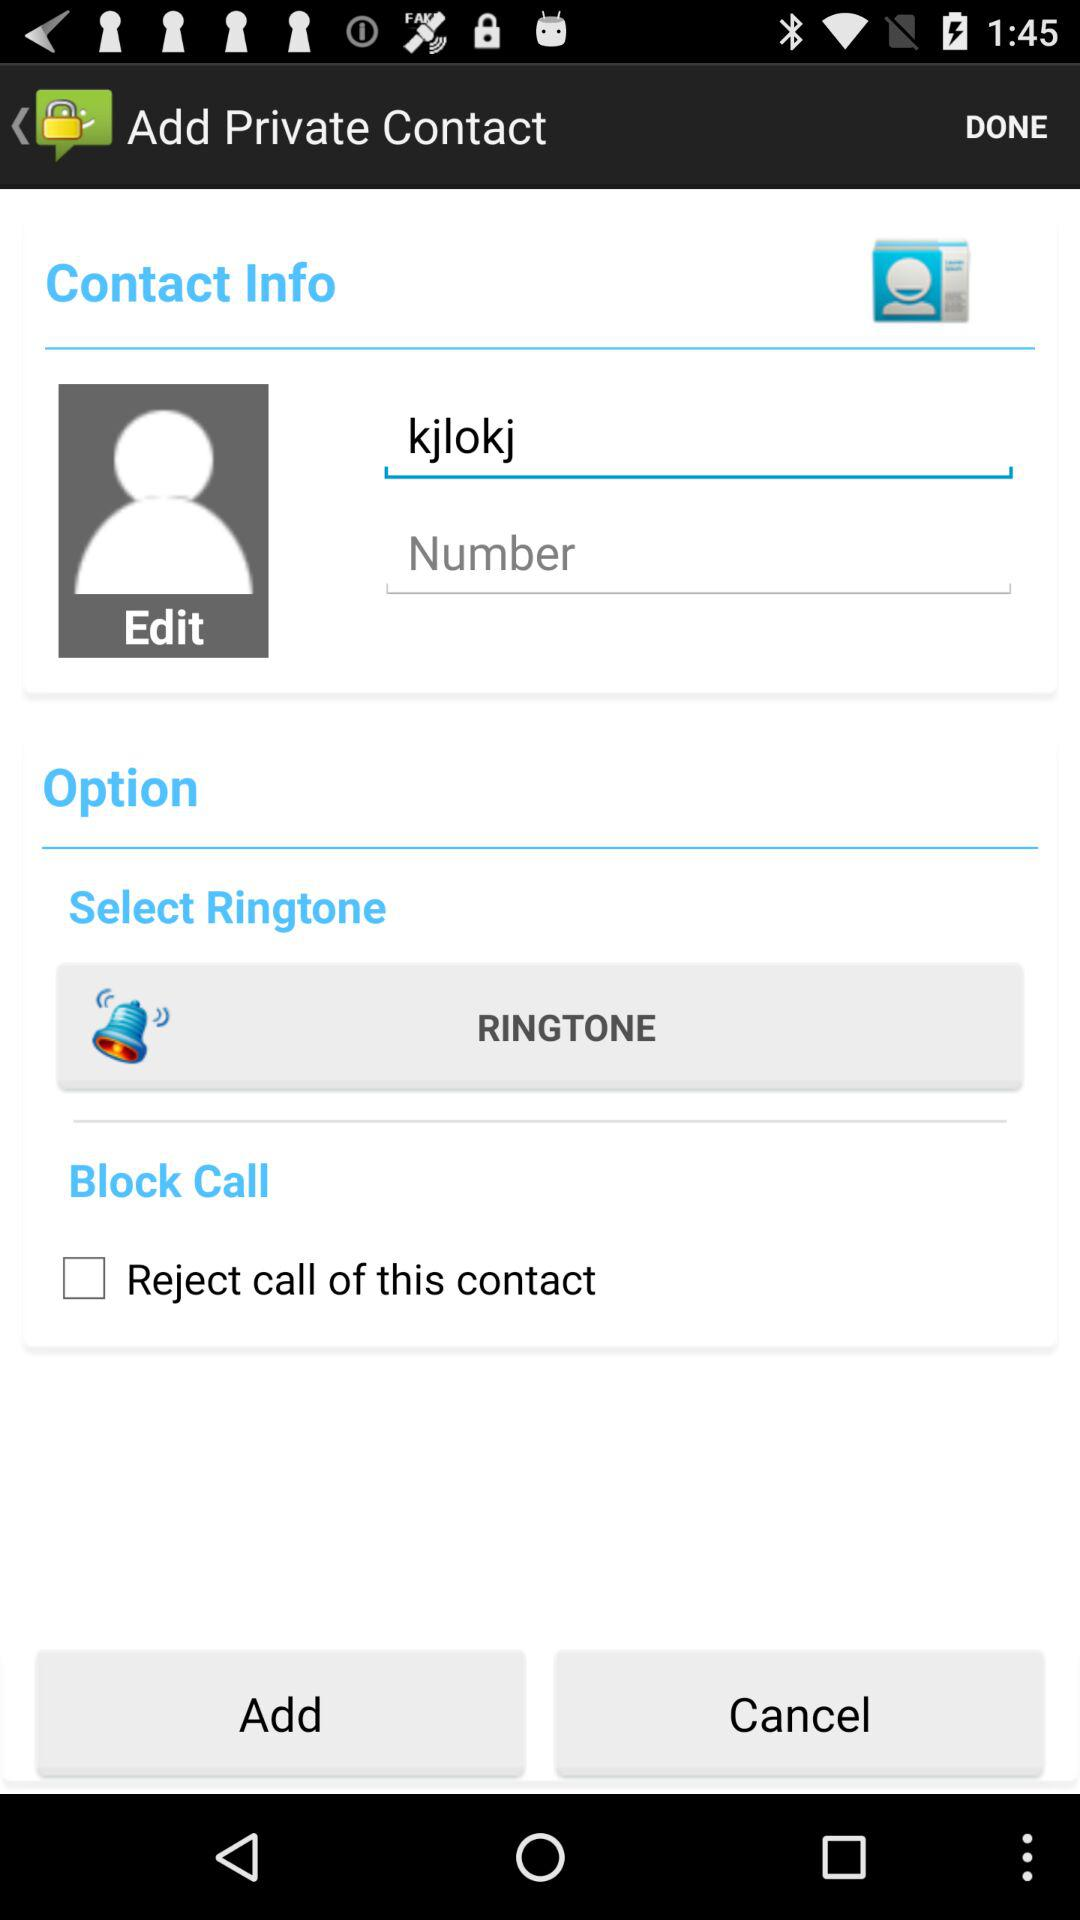How old is "kjlokj"?
When the provided information is insufficient, respond with <no answer>. <no answer> 